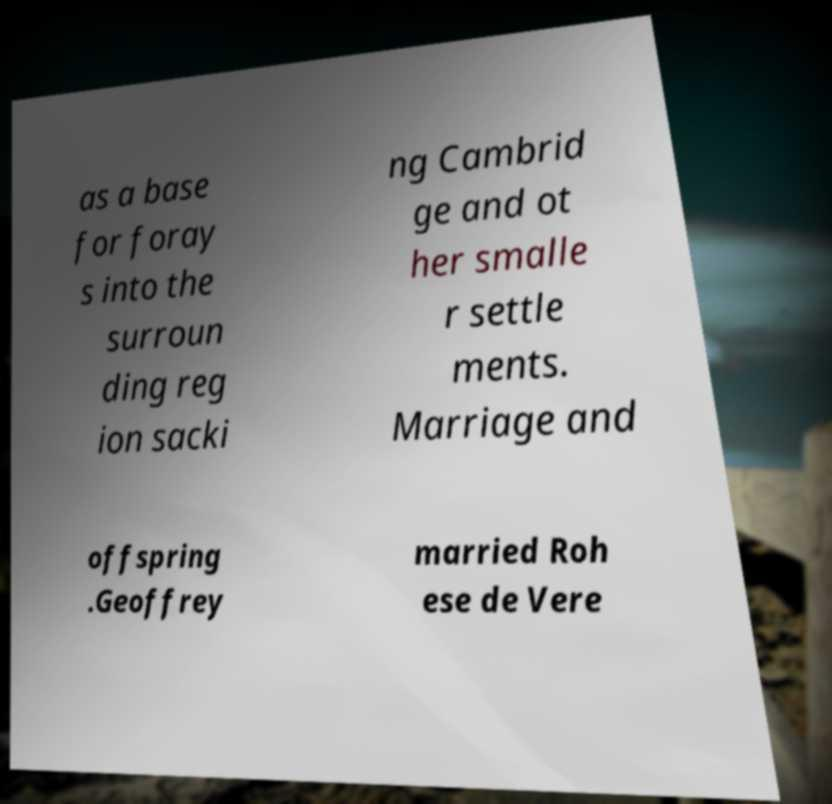Can you read and provide the text displayed in the image?This photo seems to have some interesting text. Can you extract and type it out for me? as a base for foray s into the surroun ding reg ion sacki ng Cambrid ge and ot her smalle r settle ments. Marriage and offspring .Geoffrey married Roh ese de Vere 